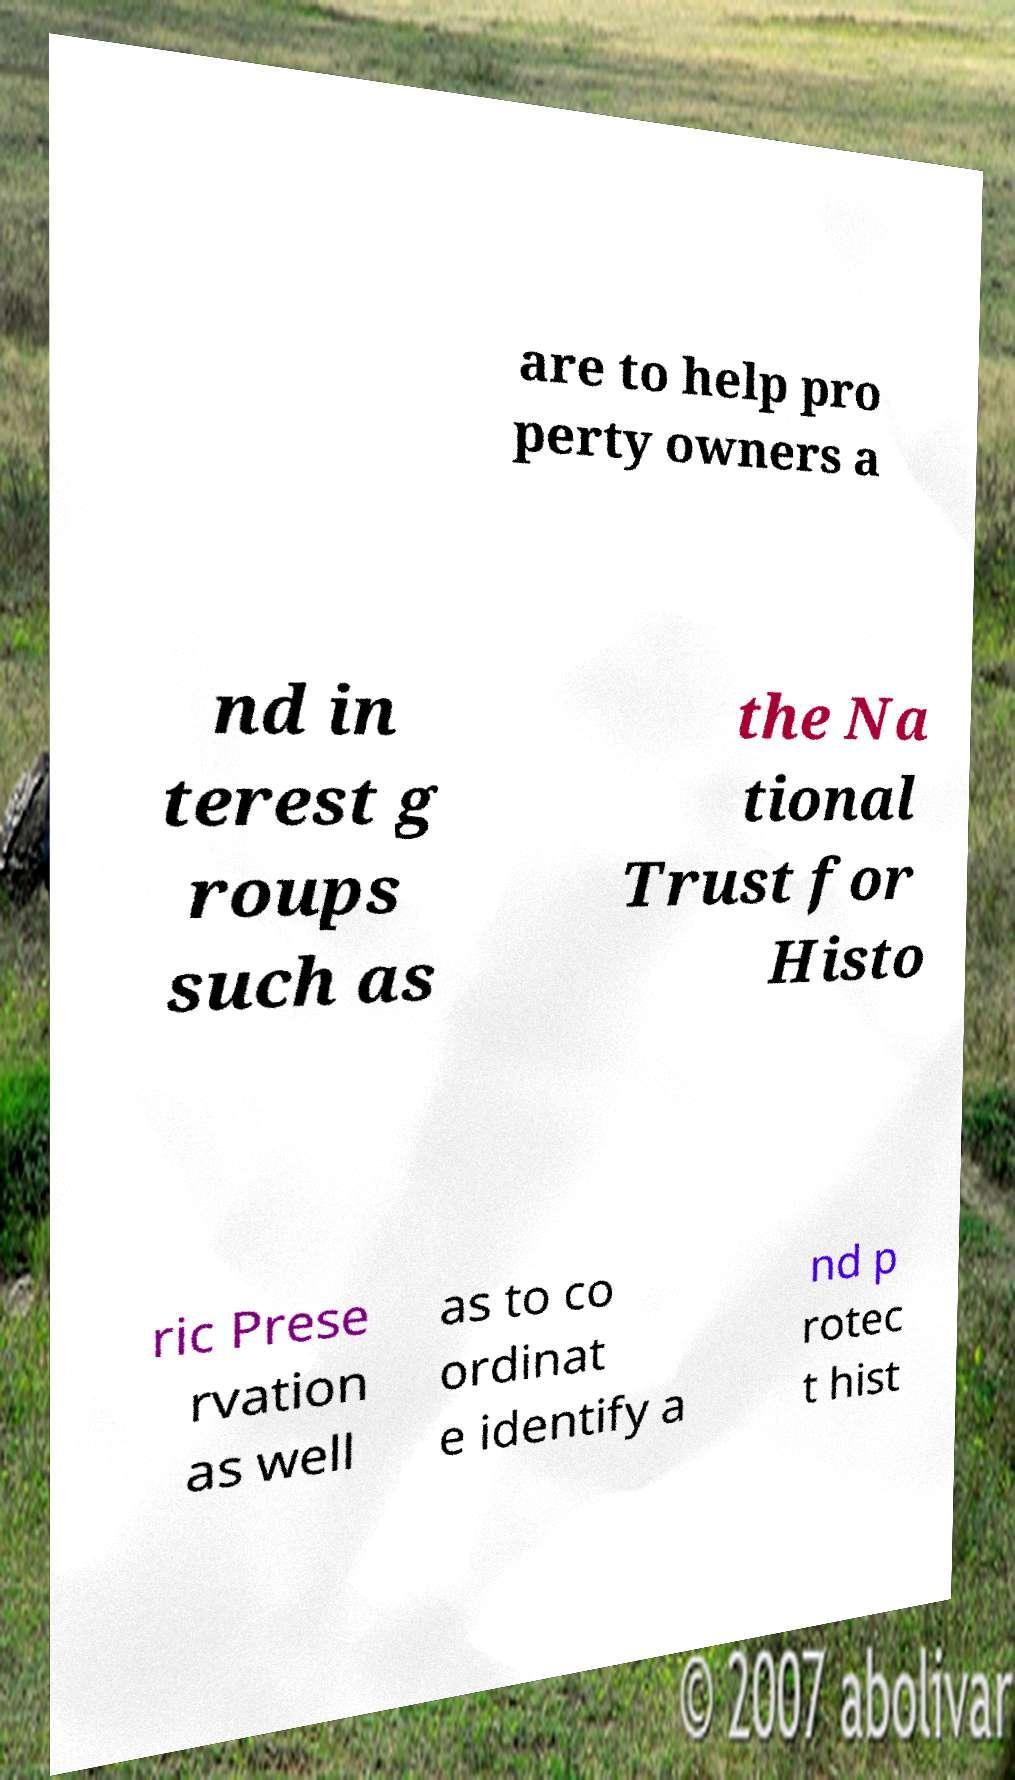Can you accurately transcribe the text from the provided image for me? are to help pro perty owners a nd in terest g roups such as the Na tional Trust for Histo ric Prese rvation as well as to co ordinat e identify a nd p rotec t hist 